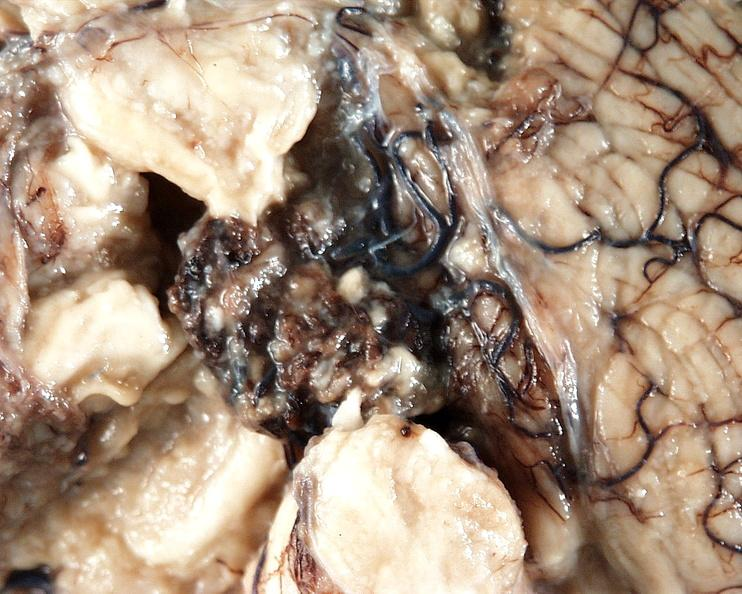s one present?
Answer the question using a single word or phrase. No 